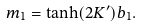Convert formula to latex. <formula><loc_0><loc_0><loc_500><loc_500>m _ { 1 } = \tanh ( 2 K ^ { \prime } ) b _ { 1 } .</formula> 